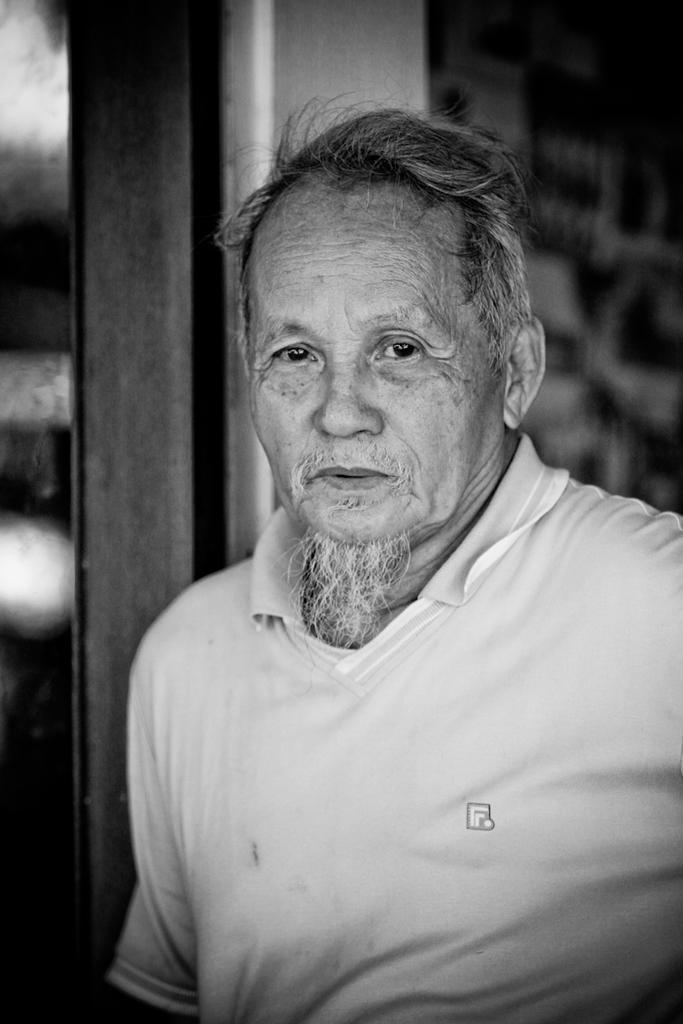Who or what is the main subject in the image? There is a person in the image. Can you describe the person's position in relation to the image? The person is in front. What is visible behind the person? There is a wall behind the person. What type of disgust can be seen on the person's face in the image? There is no indication of disgust on the person's face in the image; it is not possible to determine the person's emotions based on the provided facts. 